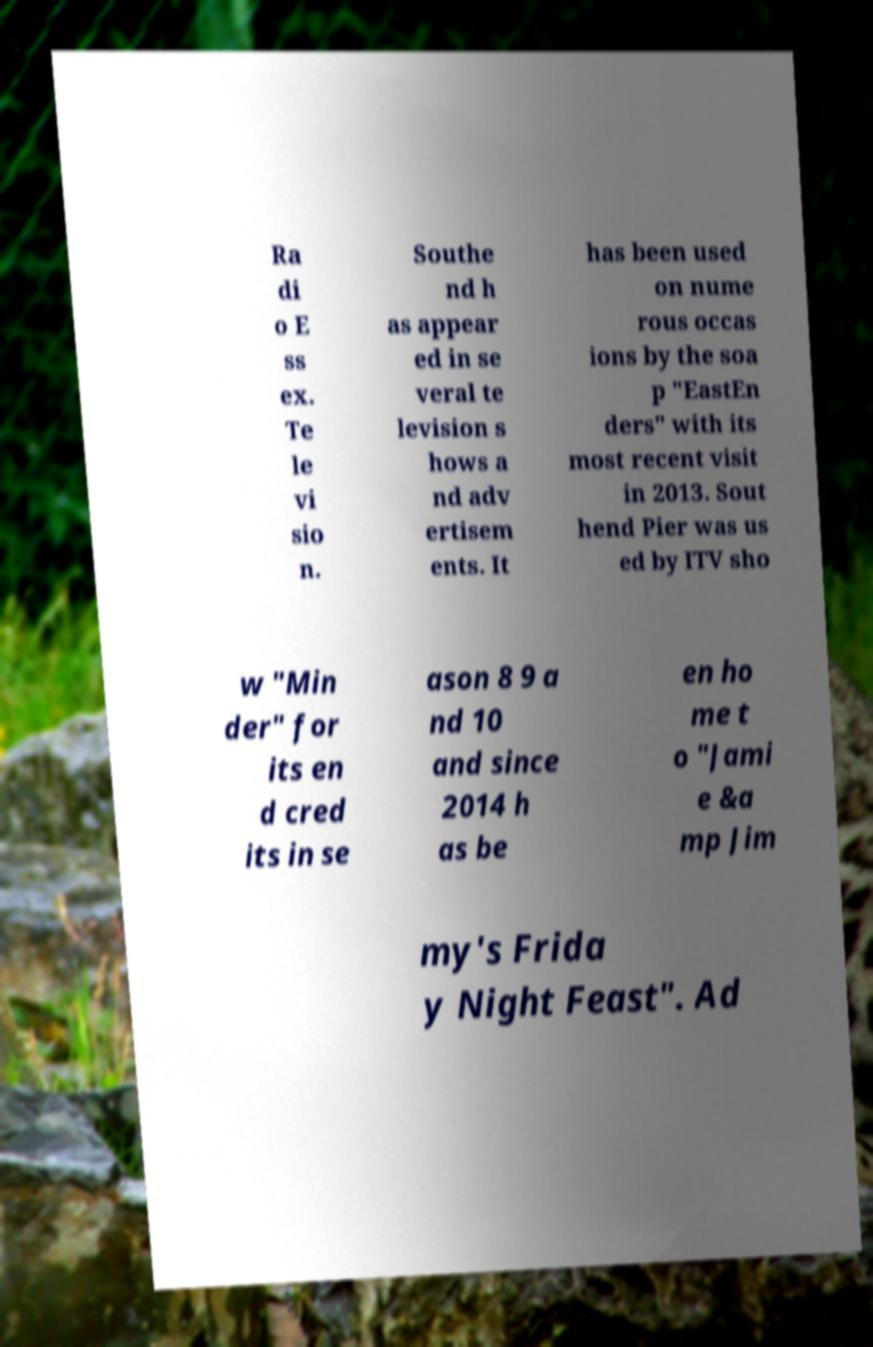Could you extract and type out the text from this image? Ra di o E ss ex. Te le vi sio n. Southe nd h as appear ed in se veral te levision s hows a nd adv ertisem ents. It has been used on nume rous occas ions by the soa p "EastEn ders" with its most recent visit in 2013. Sout hend Pier was us ed by ITV sho w "Min der" for its en d cred its in se ason 8 9 a nd 10 and since 2014 h as be en ho me t o "Jami e &a mp Jim my's Frida y Night Feast". Ad 